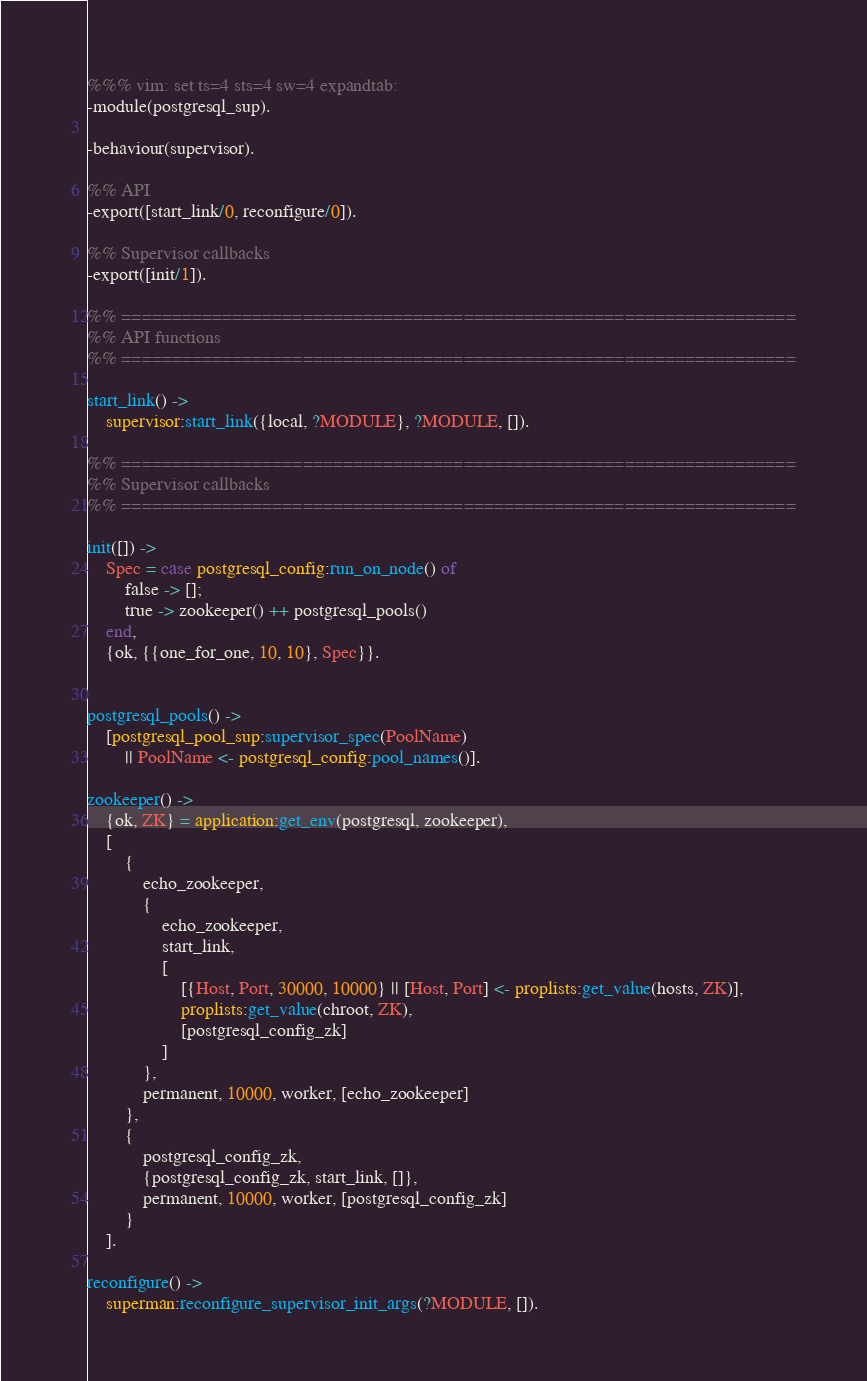<code> <loc_0><loc_0><loc_500><loc_500><_Erlang_>%%% vim: set ts=4 sts=4 sw=4 expandtab:
-module(postgresql_sup).

-behaviour(supervisor).

%% API
-export([start_link/0, reconfigure/0]).

%% Supervisor callbacks
-export([init/1]).

%% ===================================================================
%% API functions
%% ===================================================================

start_link() ->
    supervisor:start_link({local, ?MODULE}, ?MODULE, []).

%% ===================================================================
%% Supervisor callbacks
%% ===================================================================

init([]) ->
    Spec = case postgresql_config:run_on_node() of
        false -> [];
        true -> zookeeper() ++ postgresql_pools()
    end,
    {ok, {{one_for_one, 10, 10}, Spec}}.


postgresql_pools() ->
	[postgresql_pool_sup:supervisor_spec(PoolName) 
        || PoolName <- postgresql_config:pool_names()].

zookeeper() ->
    {ok, ZK} = application:get_env(postgresql, zookeeper),
	[
		{
			echo_zookeeper,
			{
				echo_zookeeper,
				start_link,
				[
					[{Host, Port, 30000, 10000} || [Host, Port] <- proplists:get_value(hosts, ZK)],
					proplists:get_value(chroot, ZK),
					[postgresql_config_zk]
				]
			},
			permanent, 10000, worker, [echo_zookeeper]
		},
		{
			postgresql_config_zk,
			{postgresql_config_zk, start_link, []},
			permanent, 10000, worker, [postgresql_config_zk]
		}
	].

reconfigure() ->
    superman:reconfigure_supervisor_init_args(?MODULE, []).
</code> 